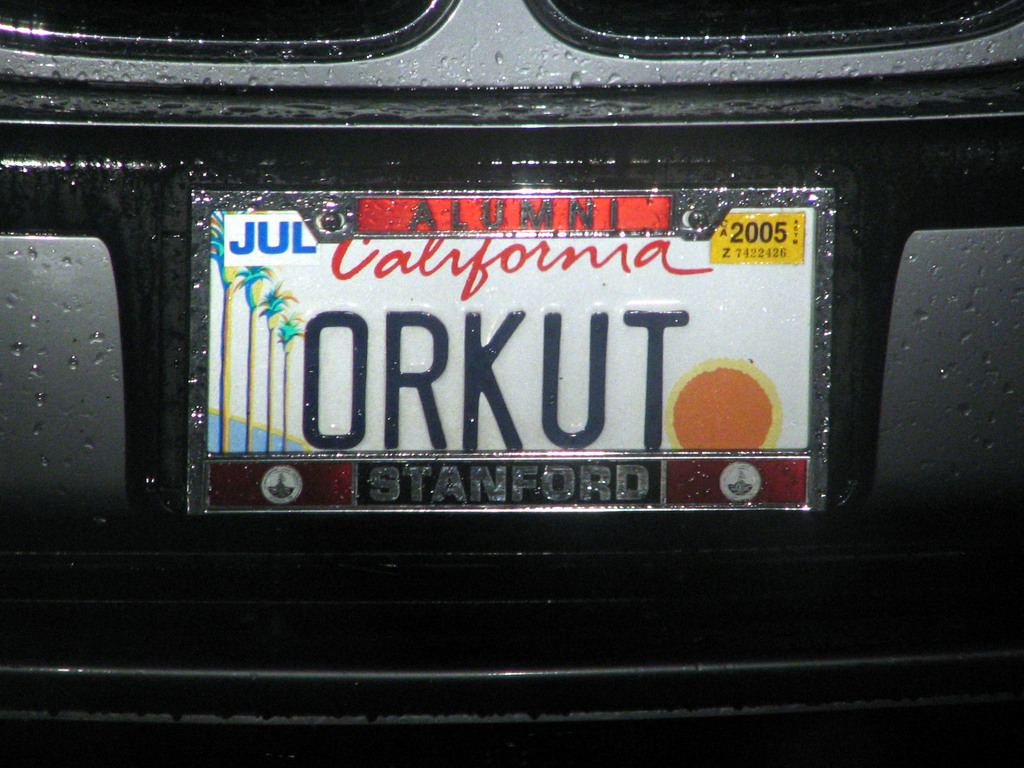What does the presence of the 'Stanford Alumni' sticker on the plate tell us? The 'Stanford Alumni' sticker signifies that the car's owner is likely a former student of Stanford University, a prestigious institution known for its academic excellence and influential alumni network. This detail not only hints at the educational background of the owner but also suggests a sense of pride in their alma mater. The placement of such a sticker on a personalized license plate can be seen as a public display of affiliation and accomplishment. 